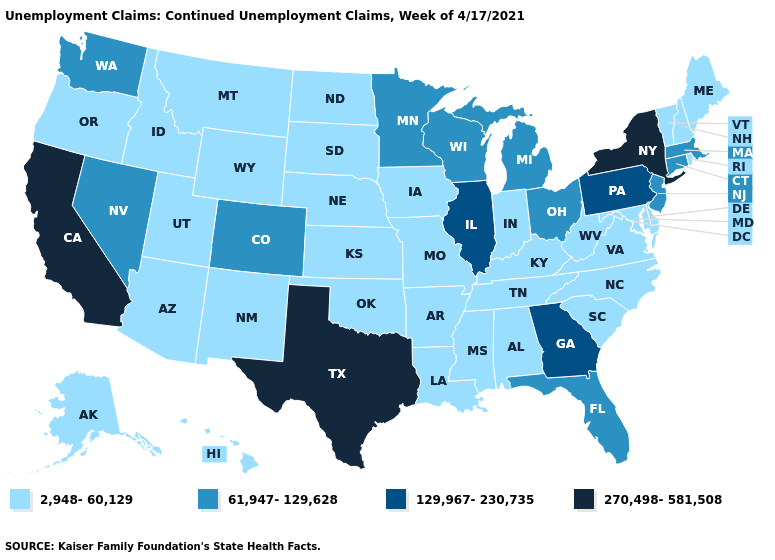What is the lowest value in the USA?
Keep it brief. 2,948-60,129. What is the highest value in the MidWest ?
Short answer required. 129,967-230,735. What is the lowest value in the USA?
Short answer required. 2,948-60,129. Does Oklahoma have the same value as Minnesota?
Quick response, please. No. Among the states that border New Mexico , does Utah have the lowest value?
Be succinct. Yes. What is the highest value in states that border Texas?
Keep it brief. 2,948-60,129. Does Alaska have the same value as Texas?
Answer briefly. No. What is the lowest value in the USA?
Be succinct. 2,948-60,129. What is the lowest value in the MidWest?
Quick response, please. 2,948-60,129. Among the states that border Ohio , does Indiana have the highest value?
Answer briefly. No. Name the states that have a value in the range 2,948-60,129?
Write a very short answer. Alabama, Alaska, Arizona, Arkansas, Delaware, Hawaii, Idaho, Indiana, Iowa, Kansas, Kentucky, Louisiana, Maine, Maryland, Mississippi, Missouri, Montana, Nebraska, New Hampshire, New Mexico, North Carolina, North Dakota, Oklahoma, Oregon, Rhode Island, South Carolina, South Dakota, Tennessee, Utah, Vermont, Virginia, West Virginia, Wyoming. Does Texas have the highest value in the South?
Quick response, please. Yes. What is the value of New Mexico?
Give a very brief answer. 2,948-60,129. Name the states that have a value in the range 270,498-581,508?
Keep it brief. California, New York, Texas. Among the states that border New Jersey , does Pennsylvania have the highest value?
Short answer required. No. 